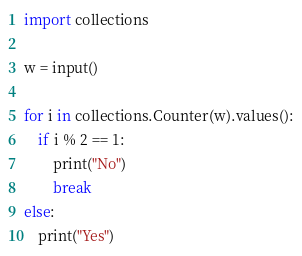<code> <loc_0><loc_0><loc_500><loc_500><_Python_>import collections

w = input()

for i in collections.Counter(w).values():
    if i % 2 == 1:
        print("No")
        break
else:
    print("Yes")</code> 